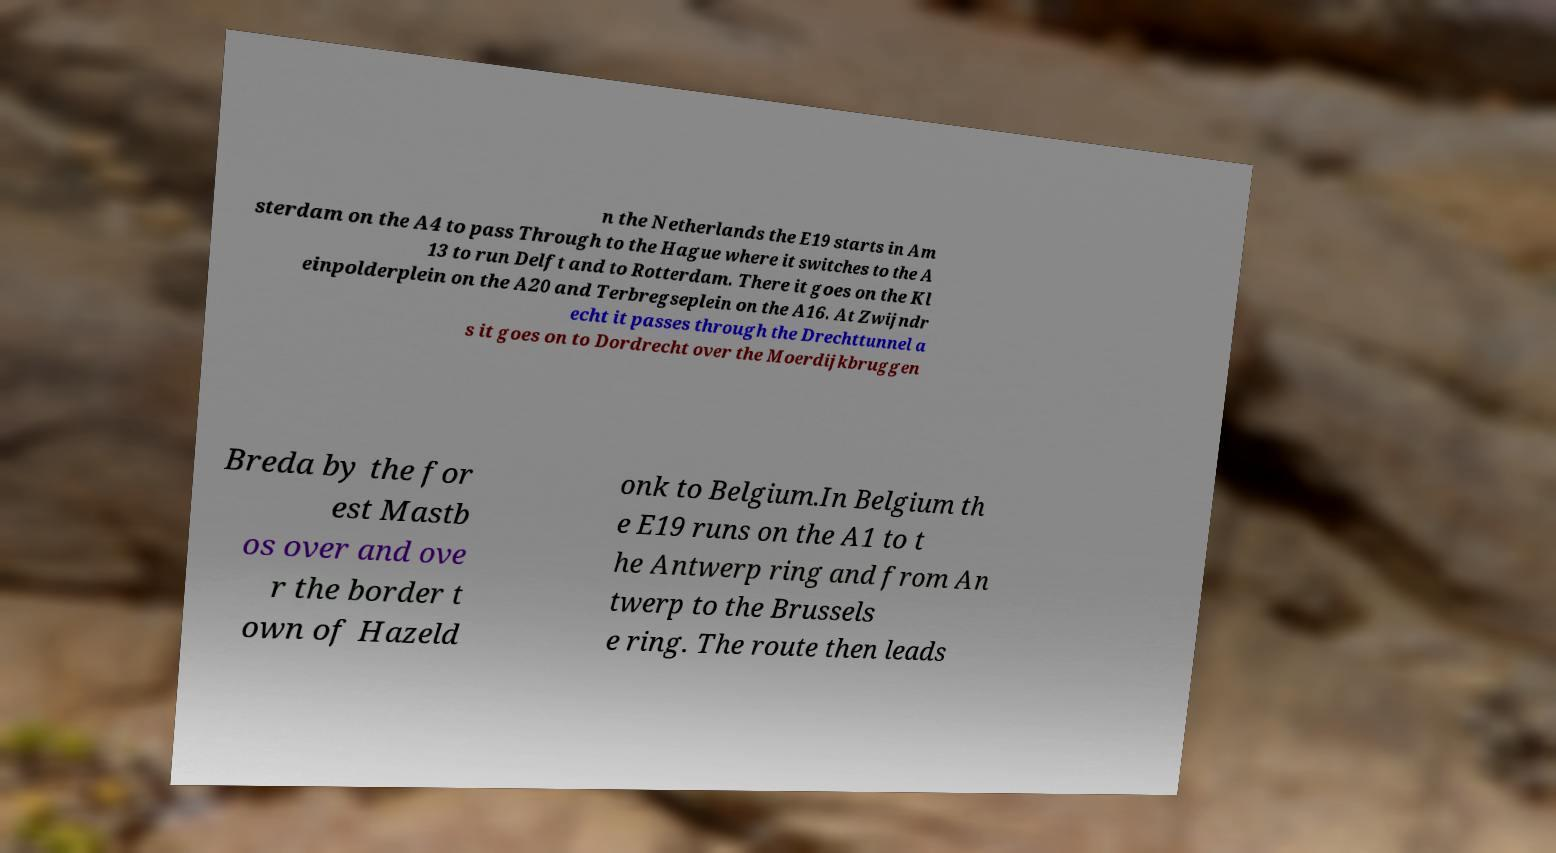Please identify and transcribe the text found in this image. n the Netherlands the E19 starts in Am sterdam on the A4 to pass Through to the Hague where it switches to the A 13 to run Delft and to Rotterdam. There it goes on the Kl einpolderplein on the A20 and Terbregseplein on the A16. At Zwijndr echt it passes through the Drechttunnel a s it goes on to Dordrecht over the Moerdijkbruggen Breda by the for est Mastb os over and ove r the border t own of Hazeld onk to Belgium.In Belgium th e E19 runs on the A1 to t he Antwerp ring and from An twerp to the Brussels e ring. The route then leads 